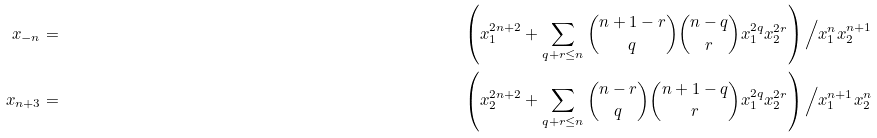<formula> <loc_0><loc_0><loc_500><loc_500>x _ { - n } & = & \left ( x _ { 1 } ^ { 2 n + 2 } + \sum _ { q + r \leq n } { n + 1 - r \choose q } { n - q \choose r } x _ { 1 } ^ { 2 q } x _ { 2 } ^ { 2 r } \right ) \Big / x _ { 1 } ^ { n } x _ { 2 } ^ { n + 1 } \\ x _ { n + 3 } & = & \left ( x _ { 2 } ^ { 2 n + 2 } + \sum _ { q + r \leq n } { n - r \choose q } { n + 1 - q \choose r } x _ { 1 } ^ { 2 q } x _ { 2 } ^ { 2 r } \right ) \Big / x _ { 1 } ^ { n + 1 } x _ { 2 } ^ { n }</formula> 